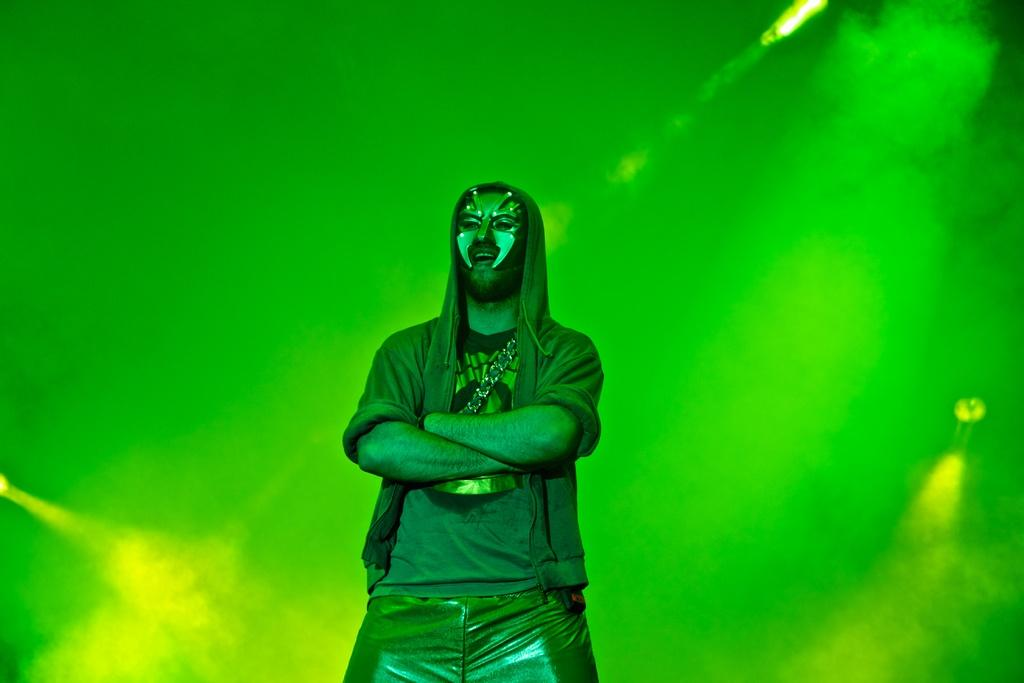What is the main subject of the image? There is a man standing in the middle of the image. What is the man wearing on his face? The man is wearing a mask. What can be seen in the background behind the man? There is fog visible behind the man. What can be seen in the image besides the man and the fog? There are lights visible in the image. What type of butter is being used to create the fog in the image? There is no butter present in the image, and the fog is not created by butter. 